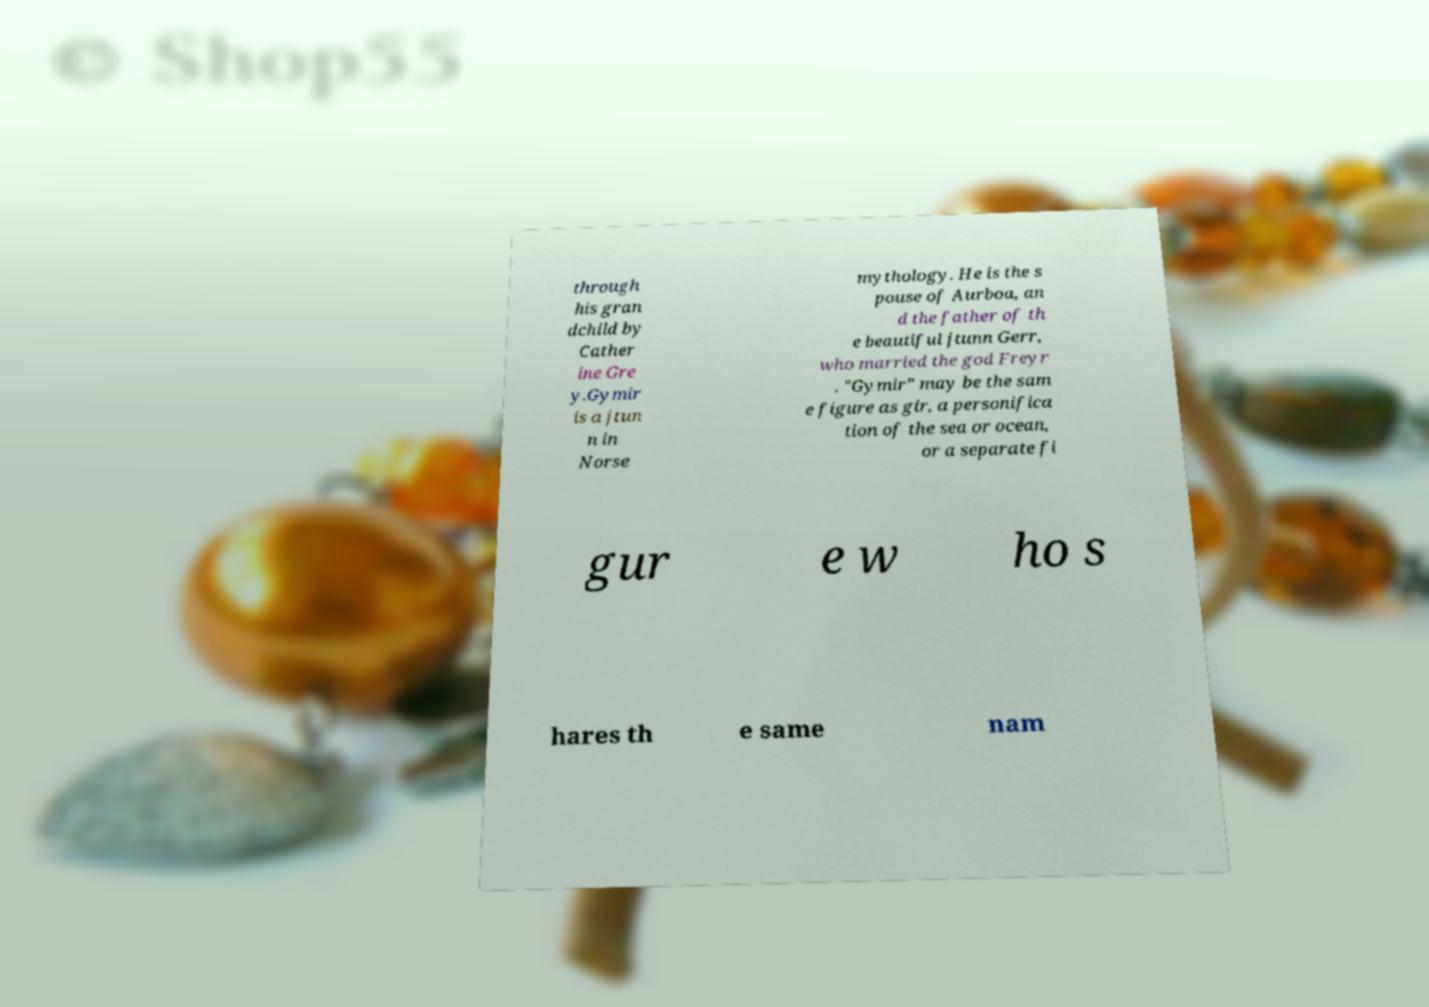Could you extract and type out the text from this image? through his gran dchild by Cather ine Gre y.Gymir is a jtun n in Norse mythology. He is the s pouse of Aurboa, an d the father of th e beautiful jtunn Gerr, who married the god Freyr . "Gymir" may be the sam e figure as gir, a personifica tion of the sea or ocean, or a separate fi gur e w ho s hares th e same nam 